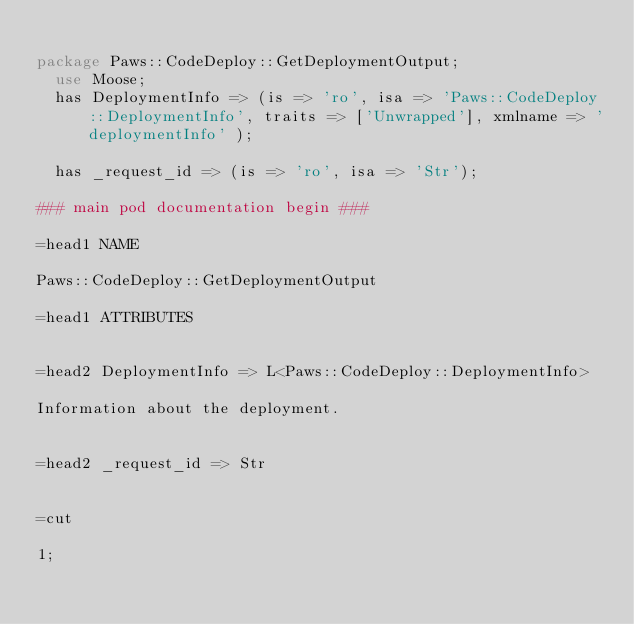<code> <loc_0><loc_0><loc_500><loc_500><_Perl_>
package Paws::CodeDeploy::GetDeploymentOutput;
  use Moose;
  has DeploymentInfo => (is => 'ro', isa => 'Paws::CodeDeploy::DeploymentInfo', traits => ['Unwrapped'], xmlname => 'deploymentInfo' );

  has _request_id => (is => 'ro', isa => 'Str');

### main pod documentation begin ###

=head1 NAME

Paws::CodeDeploy::GetDeploymentOutput

=head1 ATTRIBUTES


=head2 DeploymentInfo => L<Paws::CodeDeploy::DeploymentInfo>

Information about the deployment.


=head2 _request_id => Str


=cut

1;</code> 